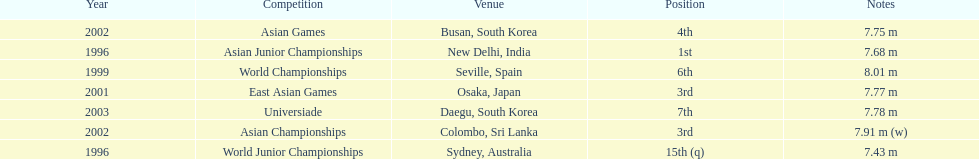How long was huang le's longest jump in 2002? 7.91 m (w). 